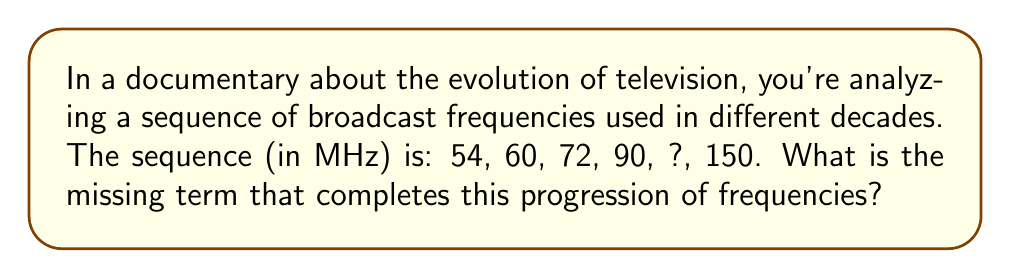Help me with this question. To solve this sequence problem, let's follow these steps:

1) First, we need to identify the pattern in the given sequence.

2) Let's calculate the differences between consecutive terms:
   $60 - 54 = 6$
   $72 - 60 = 12$
   $90 - 72 = 18$
   $150 - ? = ?$

3) We can see that the differences are increasing by 6 each time:
   $6, 12, 18, ...$

4) The next difference in this pattern would be:
   $18 + 6 = 24$

5) So, the difference between the missing term and 90 should be 24.

6) We can set up an equation:
   $? - 90 = 24$

7) Solving for the missing term:
   $? = 90 + 24 = 114$

8) We can verify this fits the pattern:
   $114 - 90 = 24$
   $150 - 114 = 36$ (which is the next term in the difference sequence: $6, 12, 18, 24, 36$)

Therefore, the missing term in the broadcast frequency sequence is 114 MHz.
Answer: 114 MHz 